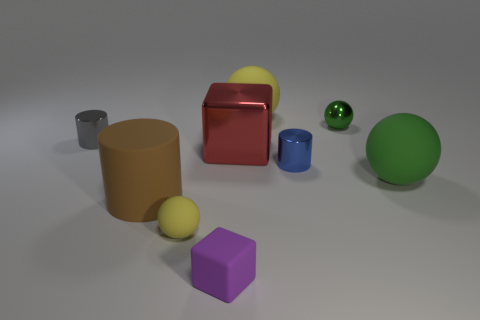There is a big brown object that is the same shape as the tiny gray shiny thing; what is it made of?
Your response must be concise. Rubber. How many brown things are either shiny balls or large matte cylinders?
Offer a terse response. 1. Are there any other things that are the same color as the big cube?
Offer a terse response. No. There is a shiny cylinder that is on the left side of the block on the left side of the big block; what color is it?
Keep it short and to the point. Gray. Are there fewer large rubber spheres that are to the left of the brown cylinder than small balls in front of the blue metal cylinder?
Make the answer very short. Yes. There is a object that is the same color as the small metal sphere; what is it made of?
Your response must be concise. Rubber. How many things are yellow rubber objects to the right of the purple object or shiny cylinders?
Your response must be concise. 3. Is the size of the cylinder to the left of the rubber cylinder the same as the purple rubber block?
Provide a short and direct response. Yes. Are there fewer large cubes that are in front of the large brown thing than small red matte cylinders?
Give a very brief answer. No. There is a block that is the same size as the gray metal object; what is its material?
Your answer should be very brief. Rubber. 